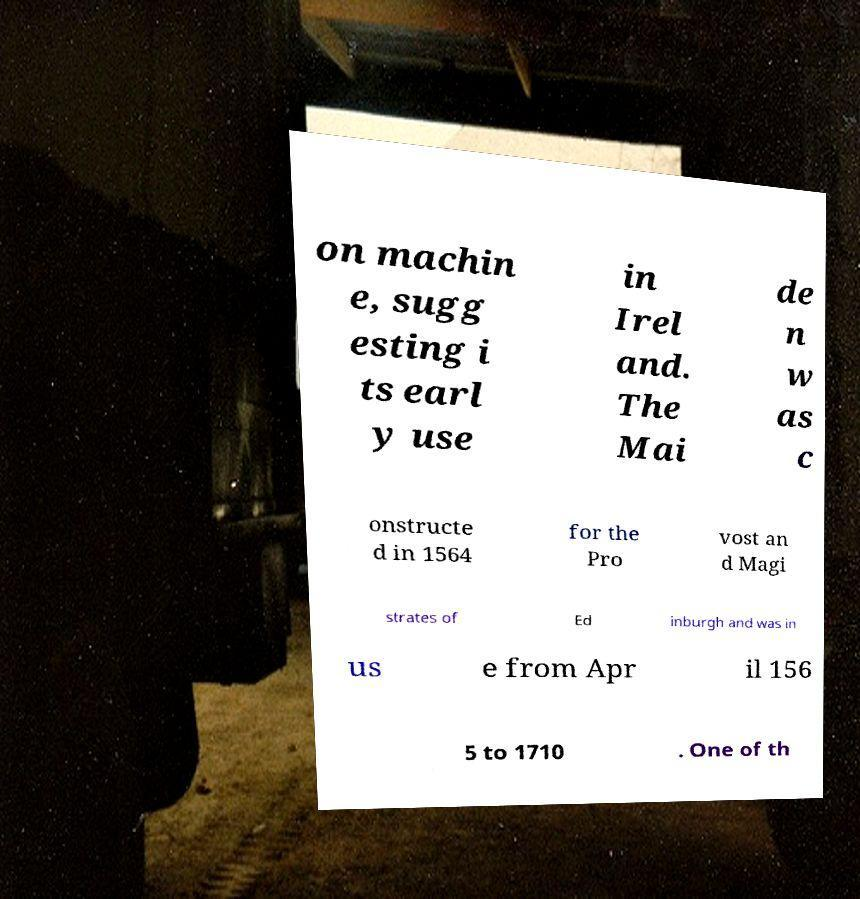Could you assist in decoding the text presented in this image and type it out clearly? on machin e, sugg esting i ts earl y use in Irel and. The Mai de n w as c onstructe d in 1564 for the Pro vost an d Magi strates of Ed inburgh and was in us e from Apr il 156 5 to 1710 . One of th 